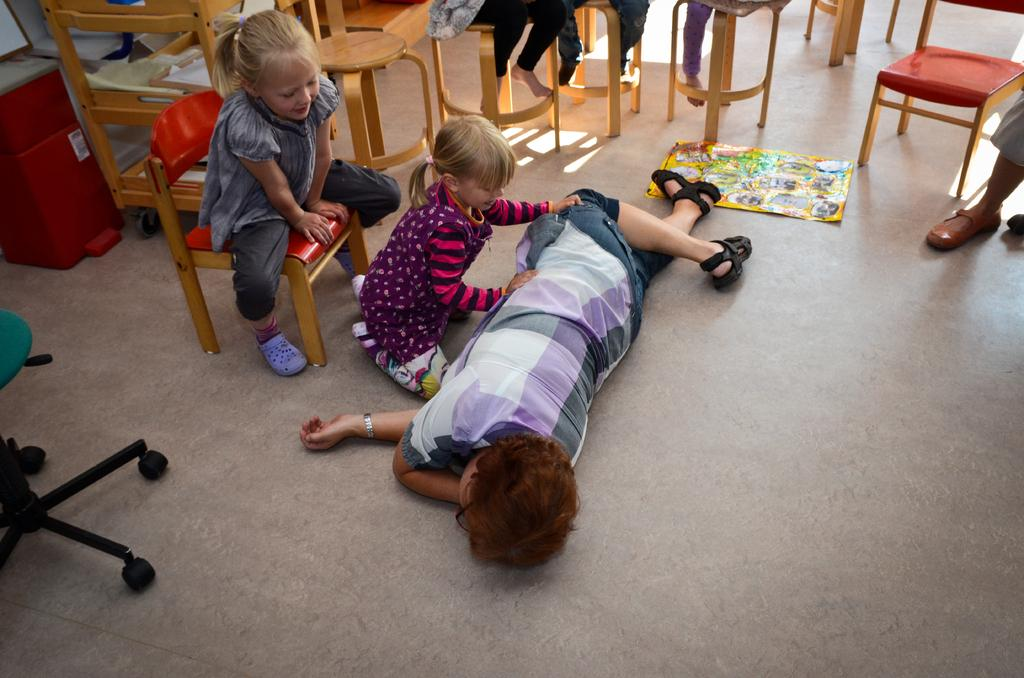Where was the image taken? The image was taken in a room. What is happening in the room? There are kids playing in the room. Can you describe the girl in the image? The girl is wearing a grey dress and is sitting on a chair. What can be seen in the background of the girl? The background of the girl includes wooden chairs. What type of substance is the girl reading in the image? There is no substance present in the image, and the girl is not reading anything. What prose is the girl reciting in the image? There is no prose or recitation happening in the image; the girl is simply sitting on a chair. 